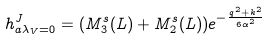<formula> <loc_0><loc_0><loc_500><loc_500>h ^ { J } _ { a \lambda _ { V } = 0 } = ( M ^ { s } _ { 3 } ( L ) + M ^ { s } _ { 2 } ( L ) ) e ^ { - \frac { { q } ^ { 2 } + { k } ^ { 2 } } { 6 \alpha ^ { 2 } } }</formula> 